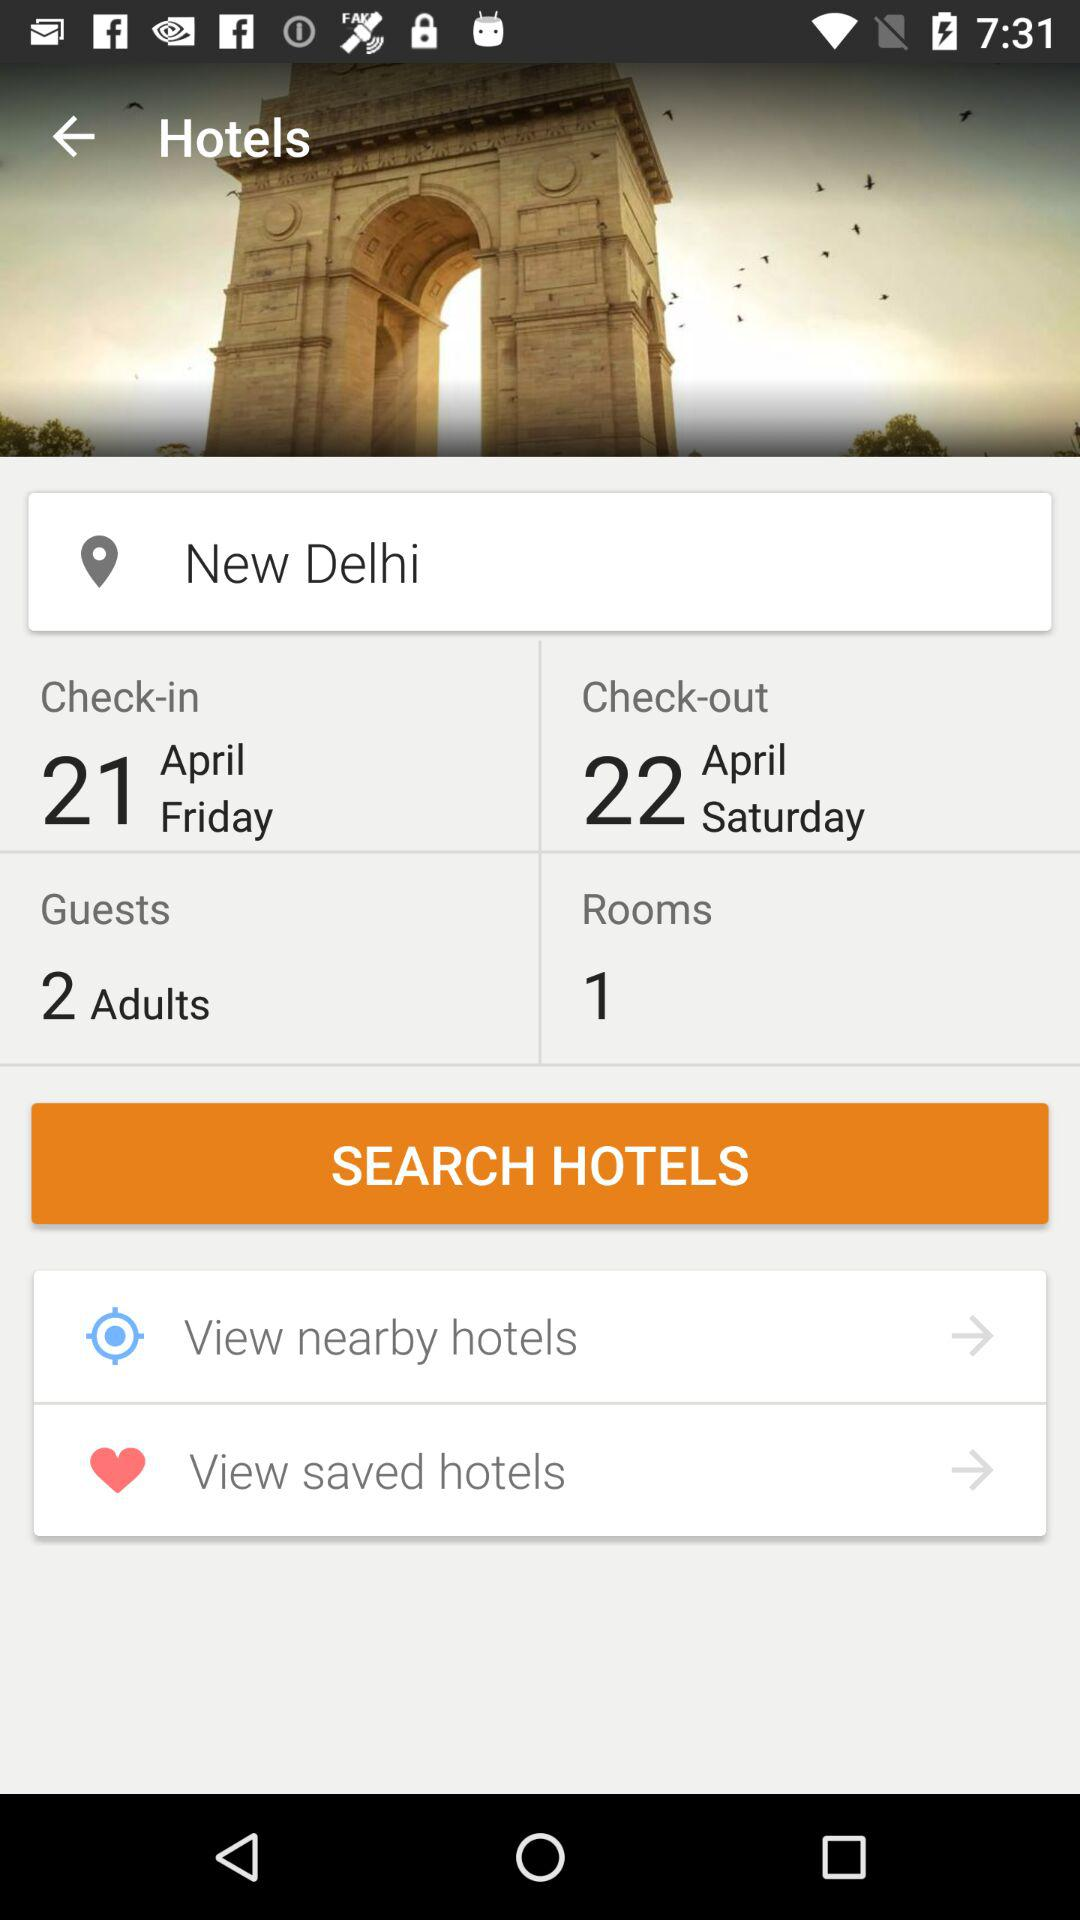For how many guests is the hotel booked? The hotel is booked for 2 guests. 